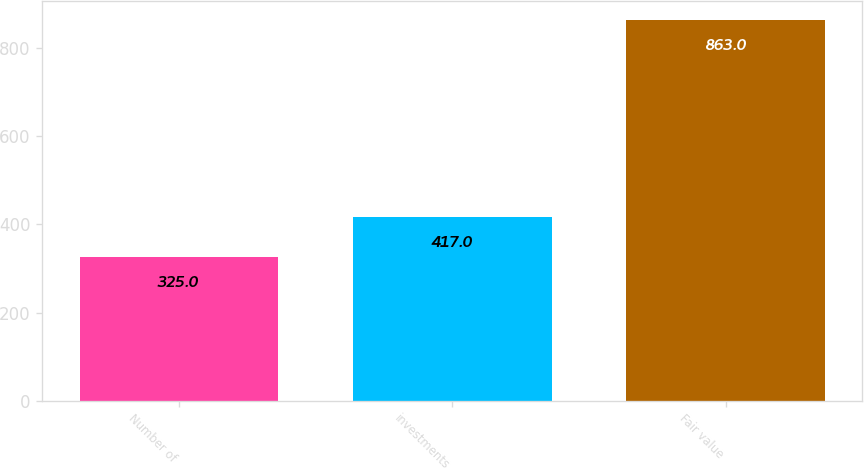<chart> <loc_0><loc_0><loc_500><loc_500><bar_chart><fcel>Number of<fcel>investments<fcel>Fair value<nl><fcel>325<fcel>417<fcel>863<nl></chart> 